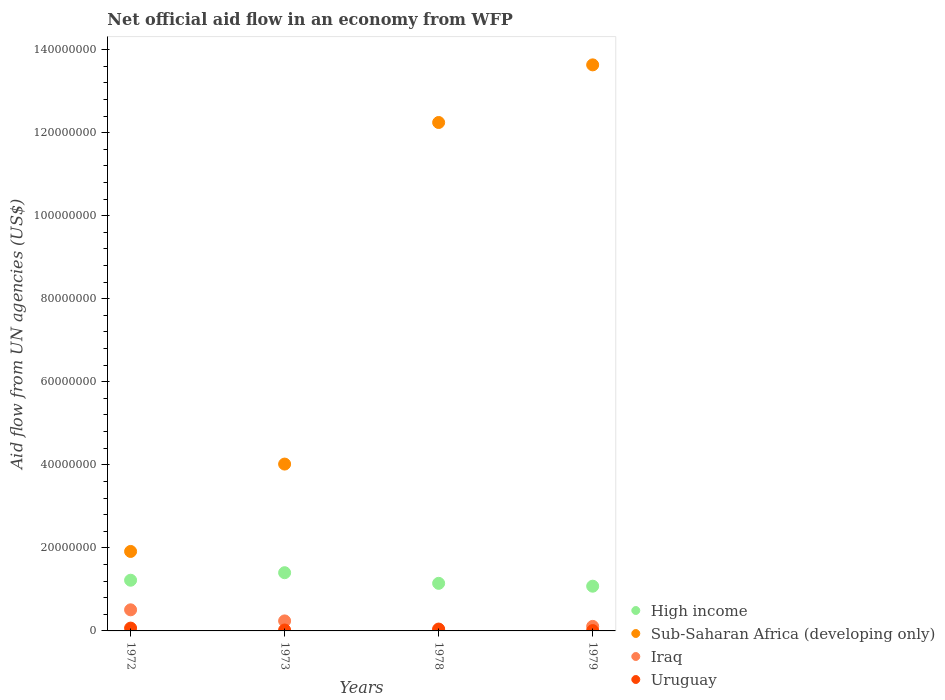Is the number of dotlines equal to the number of legend labels?
Provide a short and direct response. Yes. Across all years, what is the maximum net official aid flow in Sub-Saharan Africa (developing only)?
Make the answer very short. 1.36e+08. Across all years, what is the minimum net official aid flow in Uruguay?
Provide a short and direct response. 8.00e+04. In which year was the net official aid flow in Uruguay minimum?
Give a very brief answer. 1979. What is the total net official aid flow in High income in the graph?
Give a very brief answer. 4.85e+07. What is the difference between the net official aid flow in Sub-Saharan Africa (developing only) in 1973 and that in 1978?
Provide a succinct answer. -8.23e+07. What is the difference between the net official aid flow in High income in 1972 and the net official aid flow in Uruguay in 1978?
Provide a succinct answer. 1.18e+07. What is the average net official aid flow in High income per year?
Offer a terse response. 1.21e+07. In the year 1973, what is the difference between the net official aid flow in High income and net official aid flow in Iraq?
Your response must be concise. 1.16e+07. In how many years, is the net official aid flow in Uruguay greater than 60000000 US$?
Your answer should be very brief. 0. What is the ratio of the net official aid flow in Iraq in 1972 to that in 1978?
Ensure brevity in your answer.  22.09. What is the difference between the highest and the second highest net official aid flow in Iraq?
Offer a very short reply. 2.67e+06. Is the sum of the net official aid flow in Uruguay in 1972 and 1973 greater than the maximum net official aid flow in High income across all years?
Offer a very short reply. No. Is it the case that in every year, the sum of the net official aid flow in Iraq and net official aid flow in Uruguay  is greater than the sum of net official aid flow in Sub-Saharan Africa (developing only) and net official aid flow in High income?
Ensure brevity in your answer.  No. Is it the case that in every year, the sum of the net official aid flow in Sub-Saharan Africa (developing only) and net official aid flow in Iraq  is greater than the net official aid flow in Uruguay?
Offer a terse response. Yes. Does the net official aid flow in High income monotonically increase over the years?
Your answer should be compact. No. Is the net official aid flow in Uruguay strictly greater than the net official aid flow in High income over the years?
Your answer should be very brief. No. Does the graph contain any zero values?
Make the answer very short. No. Does the graph contain grids?
Make the answer very short. No. Where does the legend appear in the graph?
Your answer should be compact. Bottom right. How are the legend labels stacked?
Make the answer very short. Vertical. What is the title of the graph?
Keep it short and to the point. Net official aid flow in an economy from WFP. What is the label or title of the X-axis?
Give a very brief answer. Years. What is the label or title of the Y-axis?
Keep it short and to the point. Aid flow from UN agencies (US$). What is the Aid flow from UN agencies (US$) of High income in 1972?
Your response must be concise. 1.22e+07. What is the Aid flow from UN agencies (US$) in Sub-Saharan Africa (developing only) in 1972?
Offer a very short reply. 1.91e+07. What is the Aid flow from UN agencies (US$) of Iraq in 1972?
Make the answer very short. 5.08e+06. What is the Aid flow from UN agencies (US$) in Uruguay in 1972?
Make the answer very short. 6.80e+05. What is the Aid flow from UN agencies (US$) in High income in 1973?
Make the answer very short. 1.40e+07. What is the Aid flow from UN agencies (US$) of Sub-Saharan Africa (developing only) in 1973?
Your answer should be compact. 4.02e+07. What is the Aid flow from UN agencies (US$) of Iraq in 1973?
Provide a short and direct response. 2.41e+06. What is the Aid flow from UN agencies (US$) of Uruguay in 1973?
Your response must be concise. 2.20e+05. What is the Aid flow from UN agencies (US$) in High income in 1978?
Keep it short and to the point. 1.15e+07. What is the Aid flow from UN agencies (US$) of Sub-Saharan Africa (developing only) in 1978?
Ensure brevity in your answer.  1.22e+08. What is the Aid flow from UN agencies (US$) in High income in 1979?
Provide a short and direct response. 1.08e+07. What is the Aid flow from UN agencies (US$) of Sub-Saharan Africa (developing only) in 1979?
Offer a terse response. 1.36e+08. What is the Aid flow from UN agencies (US$) in Iraq in 1979?
Ensure brevity in your answer.  1.09e+06. Across all years, what is the maximum Aid flow from UN agencies (US$) of High income?
Keep it short and to the point. 1.40e+07. Across all years, what is the maximum Aid flow from UN agencies (US$) of Sub-Saharan Africa (developing only)?
Provide a succinct answer. 1.36e+08. Across all years, what is the maximum Aid flow from UN agencies (US$) of Iraq?
Your answer should be compact. 5.08e+06. Across all years, what is the maximum Aid flow from UN agencies (US$) in Uruguay?
Provide a short and direct response. 6.80e+05. Across all years, what is the minimum Aid flow from UN agencies (US$) in High income?
Keep it short and to the point. 1.08e+07. Across all years, what is the minimum Aid flow from UN agencies (US$) of Sub-Saharan Africa (developing only)?
Provide a succinct answer. 1.91e+07. Across all years, what is the minimum Aid flow from UN agencies (US$) in Uruguay?
Offer a terse response. 8.00e+04. What is the total Aid flow from UN agencies (US$) of High income in the graph?
Offer a terse response. 4.85e+07. What is the total Aid flow from UN agencies (US$) of Sub-Saharan Africa (developing only) in the graph?
Offer a very short reply. 3.18e+08. What is the total Aid flow from UN agencies (US$) of Iraq in the graph?
Your response must be concise. 8.81e+06. What is the total Aid flow from UN agencies (US$) of Uruguay in the graph?
Ensure brevity in your answer.  1.43e+06. What is the difference between the Aid flow from UN agencies (US$) of High income in 1972 and that in 1973?
Your answer should be compact. -1.81e+06. What is the difference between the Aid flow from UN agencies (US$) of Sub-Saharan Africa (developing only) in 1972 and that in 1973?
Your response must be concise. -2.10e+07. What is the difference between the Aid flow from UN agencies (US$) of Iraq in 1972 and that in 1973?
Your response must be concise. 2.67e+06. What is the difference between the Aid flow from UN agencies (US$) of Uruguay in 1972 and that in 1973?
Offer a very short reply. 4.60e+05. What is the difference between the Aid flow from UN agencies (US$) in High income in 1972 and that in 1978?
Give a very brief answer. 7.50e+05. What is the difference between the Aid flow from UN agencies (US$) of Sub-Saharan Africa (developing only) in 1972 and that in 1978?
Your answer should be very brief. -1.03e+08. What is the difference between the Aid flow from UN agencies (US$) in Iraq in 1972 and that in 1978?
Give a very brief answer. 4.85e+06. What is the difference between the Aid flow from UN agencies (US$) of High income in 1972 and that in 1979?
Keep it short and to the point. 1.44e+06. What is the difference between the Aid flow from UN agencies (US$) of Sub-Saharan Africa (developing only) in 1972 and that in 1979?
Your response must be concise. -1.17e+08. What is the difference between the Aid flow from UN agencies (US$) of Iraq in 1972 and that in 1979?
Give a very brief answer. 3.99e+06. What is the difference between the Aid flow from UN agencies (US$) in High income in 1973 and that in 1978?
Provide a short and direct response. 2.56e+06. What is the difference between the Aid flow from UN agencies (US$) of Sub-Saharan Africa (developing only) in 1973 and that in 1978?
Ensure brevity in your answer.  -8.23e+07. What is the difference between the Aid flow from UN agencies (US$) of Iraq in 1973 and that in 1978?
Keep it short and to the point. 2.18e+06. What is the difference between the Aid flow from UN agencies (US$) in Uruguay in 1973 and that in 1978?
Offer a terse response. -2.30e+05. What is the difference between the Aid flow from UN agencies (US$) of High income in 1973 and that in 1979?
Your response must be concise. 3.25e+06. What is the difference between the Aid flow from UN agencies (US$) of Sub-Saharan Africa (developing only) in 1973 and that in 1979?
Provide a short and direct response. -9.61e+07. What is the difference between the Aid flow from UN agencies (US$) in Iraq in 1973 and that in 1979?
Keep it short and to the point. 1.32e+06. What is the difference between the Aid flow from UN agencies (US$) in Uruguay in 1973 and that in 1979?
Offer a terse response. 1.40e+05. What is the difference between the Aid flow from UN agencies (US$) in High income in 1978 and that in 1979?
Give a very brief answer. 6.90e+05. What is the difference between the Aid flow from UN agencies (US$) of Sub-Saharan Africa (developing only) in 1978 and that in 1979?
Your response must be concise. -1.39e+07. What is the difference between the Aid flow from UN agencies (US$) in Iraq in 1978 and that in 1979?
Provide a short and direct response. -8.60e+05. What is the difference between the Aid flow from UN agencies (US$) of High income in 1972 and the Aid flow from UN agencies (US$) of Sub-Saharan Africa (developing only) in 1973?
Give a very brief answer. -2.80e+07. What is the difference between the Aid flow from UN agencies (US$) of High income in 1972 and the Aid flow from UN agencies (US$) of Iraq in 1973?
Your answer should be very brief. 9.80e+06. What is the difference between the Aid flow from UN agencies (US$) of High income in 1972 and the Aid flow from UN agencies (US$) of Uruguay in 1973?
Provide a succinct answer. 1.20e+07. What is the difference between the Aid flow from UN agencies (US$) in Sub-Saharan Africa (developing only) in 1972 and the Aid flow from UN agencies (US$) in Iraq in 1973?
Give a very brief answer. 1.67e+07. What is the difference between the Aid flow from UN agencies (US$) of Sub-Saharan Africa (developing only) in 1972 and the Aid flow from UN agencies (US$) of Uruguay in 1973?
Your answer should be very brief. 1.89e+07. What is the difference between the Aid flow from UN agencies (US$) of Iraq in 1972 and the Aid flow from UN agencies (US$) of Uruguay in 1973?
Ensure brevity in your answer.  4.86e+06. What is the difference between the Aid flow from UN agencies (US$) in High income in 1972 and the Aid flow from UN agencies (US$) in Sub-Saharan Africa (developing only) in 1978?
Your response must be concise. -1.10e+08. What is the difference between the Aid flow from UN agencies (US$) in High income in 1972 and the Aid flow from UN agencies (US$) in Iraq in 1978?
Ensure brevity in your answer.  1.20e+07. What is the difference between the Aid flow from UN agencies (US$) in High income in 1972 and the Aid flow from UN agencies (US$) in Uruguay in 1978?
Ensure brevity in your answer.  1.18e+07. What is the difference between the Aid flow from UN agencies (US$) of Sub-Saharan Africa (developing only) in 1972 and the Aid flow from UN agencies (US$) of Iraq in 1978?
Your response must be concise. 1.89e+07. What is the difference between the Aid flow from UN agencies (US$) in Sub-Saharan Africa (developing only) in 1972 and the Aid flow from UN agencies (US$) in Uruguay in 1978?
Give a very brief answer. 1.87e+07. What is the difference between the Aid flow from UN agencies (US$) in Iraq in 1972 and the Aid flow from UN agencies (US$) in Uruguay in 1978?
Offer a very short reply. 4.63e+06. What is the difference between the Aid flow from UN agencies (US$) in High income in 1972 and the Aid flow from UN agencies (US$) in Sub-Saharan Africa (developing only) in 1979?
Offer a very short reply. -1.24e+08. What is the difference between the Aid flow from UN agencies (US$) in High income in 1972 and the Aid flow from UN agencies (US$) in Iraq in 1979?
Provide a succinct answer. 1.11e+07. What is the difference between the Aid flow from UN agencies (US$) of High income in 1972 and the Aid flow from UN agencies (US$) of Uruguay in 1979?
Provide a succinct answer. 1.21e+07. What is the difference between the Aid flow from UN agencies (US$) of Sub-Saharan Africa (developing only) in 1972 and the Aid flow from UN agencies (US$) of Iraq in 1979?
Give a very brief answer. 1.80e+07. What is the difference between the Aid flow from UN agencies (US$) of Sub-Saharan Africa (developing only) in 1972 and the Aid flow from UN agencies (US$) of Uruguay in 1979?
Provide a short and direct response. 1.91e+07. What is the difference between the Aid flow from UN agencies (US$) of High income in 1973 and the Aid flow from UN agencies (US$) of Sub-Saharan Africa (developing only) in 1978?
Make the answer very short. -1.08e+08. What is the difference between the Aid flow from UN agencies (US$) of High income in 1973 and the Aid flow from UN agencies (US$) of Iraq in 1978?
Give a very brief answer. 1.38e+07. What is the difference between the Aid flow from UN agencies (US$) in High income in 1973 and the Aid flow from UN agencies (US$) in Uruguay in 1978?
Offer a very short reply. 1.36e+07. What is the difference between the Aid flow from UN agencies (US$) of Sub-Saharan Africa (developing only) in 1973 and the Aid flow from UN agencies (US$) of Iraq in 1978?
Your answer should be compact. 4.00e+07. What is the difference between the Aid flow from UN agencies (US$) of Sub-Saharan Africa (developing only) in 1973 and the Aid flow from UN agencies (US$) of Uruguay in 1978?
Offer a very short reply. 3.97e+07. What is the difference between the Aid flow from UN agencies (US$) in Iraq in 1973 and the Aid flow from UN agencies (US$) in Uruguay in 1978?
Offer a terse response. 1.96e+06. What is the difference between the Aid flow from UN agencies (US$) of High income in 1973 and the Aid flow from UN agencies (US$) of Sub-Saharan Africa (developing only) in 1979?
Provide a succinct answer. -1.22e+08. What is the difference between the Aid flow from UN agencies (US$) of High income in 1973 and the Aid flow from UN agencies (US$) of Iraq in 1979?
Your answer should be compact. 1.29e+07. What is the difference between the Aid flow from UN agencies (US$) in High income in 1973 and the Aid flow from UN agencies (US$) in Uruguay in 1979?
Offer a terse response. 1.39e+07. What is the difference between the Aid flow from UN agencies (US$) of Sub-Saharan Africa (developing only) in 1973 and the Aid flow from UN agencies (US$) of Iraq in 1979?
Offer a terse response. 3.91e+07. What is the difference between the Aid flow from UN agencies (US$) of Sub-Saharan Africa (developing only) in 1973 and the Aid flow from UN agencies (US$) of Uruguay in 1979?
Your answer should be very brief. 4.01e+07. What is the difference between the Aid flow from UN agencies (US$) in Iraq in 1973 and the Aid flow from UN agencies (US$) in Uruguay in 1979?
Provide a succinct answer. 2.33e+06. What is the difference between the Aid flow from UN agencies (US$) of High income in 1978 and the Aid flow from UN agencies (US$) of Sub-Saharan Africa (developing only) in 1979?
Your answer should be very brief. -1.25e+08. What is the difference between the Aid flow from UN agencies (US$) in High income in 1978 and the Aid flow from UN agencies (US$) in Iraq in 1979?
Provide a short and direct response. 1.04e+07. What is the difference between the Aid flow from UN agencies (US$) in High income in 1978 and the Aid flow from UN agencies (US$) in Uruguay in 1979?
Your answer should be compact. 1.14e+07. What is the difference between the Aid flow from UN agencies (US$) of Sub-Saharan Africa (developing only) in 1978 and the Aid flow from UN agencies (US$) of Iraq in 1979?
Ensure brevity in your answer.  1.21e+08. What is the difference between the Aid flow from UN agencies (US$) of Sub-Saharan Africa (developing only) in 1978 and the Aid flow from UN agencies (US$) of Uruguay in 1979?
Make the answer very short. 1.22e+08. What is the difference between the Aid flow from UN agencies (US$) in Iraq in 1978 and the Aid flow from UN agencies (US$) in Uruguay in 1979?
Provide a short and direct response. 1.50e+05. What is the average Aid flow from UN agencies (US$) of High income per year?
Offer a very short reply. 1.21e+07. What is the average Aid flow from UN agencies (US$) of Sub-Saharan Africa (developing only) per year?
Ensure brevity in your answer.  7.95e+07. What is the average Aid flow from UN agencies (US$) in Iraq per year?
Your answer should be very brief. 2.20e+06. What is the average Aid flow from UN agencies (US$) of Uruguay per year?
Give a very brief answer. 3.58e+05. In the year 1972, what is the difference between the Aid flow from UN agencies (US$) in High income and Aid flow from UN agencies (US$) in Sub-Saharan Africa (developing only)?
Your answer should be compact. -6.93e+06. In the year 1972, what is the difference between the Aid flow from UN agencies (US$) in High income and Aid flow from UN agencies (US$) in Iraq?
Ensure brevity in your answer.  7.13e+06. In the year 1972, what is the difference between the Aid flow from UN agencies (US$) in High income and Aid flow from UN agencies (US$) in Uruguay?
Give a very brief answer. 1.15e+07. In the year 1972, what is the difference between the Aid flow from UN agencies (US$) of Sub-Saharan Africa (developing only) and Aid flow from UN agencies (US$) of Iraq?
Provide a succinct answer. 1.41e+07. In the year 1972, what is the difference between the Aid flow from UN agencies (US$) in Sub-Saharan Africa (developing only) and Aid flow from UN agencies (US$) in Uruguay?
Give a very brief answer. 1.85e+07. In the year 1972, what is the difference between the Aid flow from UN agencies (US$) in Iraq and Aid flow from UN agencies (US$) in Uruguay?
Your answer should be very brief. 4.40e+06. In the year 1973, what is the difference between the Aid flow from UN agencies (US$) of High income and Aid flow from UN agencies (US$) of Sub-Saharan Africa (developing only)?
Give a very brief answer. -2.62e+07. In the year 1973, what is the difference between the Aid flow from UN agencies (US$) of High income and Aid flow from UN agencies (US$) of Iraq?
Ensure brevity in your answer.  1.16e+07. In the year 1973, what is the difference between the Aid flow from UN agencies (US$) in High income and Aid flow from UN agencies (US$) in Uruguay?
Give a very brief answer. 1.38e+07. In the year 1973, what is the difference between the Aid flow from UN agencies (US$) in Sub-Saharan Africa (developing only) and Aid flow from UN agencies (US$) in Iraq?
Provide a succinct answer. 3.78e+07. In the year 1973, what is the difference between the Aid flow from UN agencies (US$) in Sub-Saharan Africa (developing only) and Aid flow from UN agencies (US$) in Uruguay?
Offer a very short reply. 4.00e+07. In the year 1973, what is the difference between the Aid flow from UN agencies (US$) in Iraq and Aid flow from UN agencies (US$) in Uruguay?
Provide a succinct answer. 2.19e+06. In the year 1978, what is the difference between the Aid flow from UN agencies (US$) in High income and Aid flow from UN agencies (US$) in Sub-Saharan Africa (developing only)?
Your answer should be compact. -1.11e+08. In the year 1978, what is the difference between the Aid flow from UN agencies (US$) of High income and Aid flow from UN agencies (US$) of Iraq?
Offer a terse response. 1.12e+07. In the year 1978, what is the difference between the Aid flow from UN agencies (US$) of High income and Aid flow from UN agencies (US$) of Uruguay?
Your answer should be very brief. 1.10e+07. In the year 1978, what is the difference between the Aid flow from UN agencies (US$) in Sub-Saharan Africa (developing only) and Aid flow from UN agencies (US$) in Iraq?
Give a very brief answer. 1.22e+08. In the year 1978, what is the difference between the Aid flow from UN agencies (US$) in Sub-Saharan Africa (developing only) and Aid flow from UN agencies (US$) in Uruguay?
Keep it short and to the point. 1.22e+08. In the year 1979, what is the difference between the Aid flow from UN agencies (US$) in High income and Aid flow from UN agencies (US$) in Sub-Saharan Africa (developing only)?
Make the answer very short. -1.26e+08. In the year 1979, what is the difference between the Aid flow from UN agencies (US$) of High income and Aid flow from UN agencies (US$) of Iraq?
Ensure brevity in your answer.  9.68e+06. In the year 1979, what is the difference between the Aid flow from UN agencies (US$) of High income and Aid flow from UN agencies (US$) of Uruguay?
Keep it short and to the point. 1.07e+07. In the year 1979, what is the difference between the Aid flow from UN agencies (US$) in Sub-Saharan Africa (developing only) and Aid flow from UN agencies (US$) in Iraq?
Provide a succinct answer. 1.35e+08. In the year 1979, what is the difference between the Aid flow from UN agencies (US$) in Sub-Saharan Africa (developing only) and Aid flow from UN agencies (US$) in Uruguay?
Your answer should be compact. 1.36e+08. In the year 1979, what is the difference between the Aid flow from UN agencies (US$) in Iraq and Aid flow from UN agencies (US$) in Uruguay?
Provide a short and direct response. 1.01e+06. What is the ratio of the Aid flow from UN agencies (US$) in High income in 1972 to that in 1973?
Your answer should be very brief. 0.87. What is the ratio of the Aid flow from UN agencies (US$) in Sub-Saharan Africa (developing only) in 1972 to that in 1973?
Offer a terse response. 0.48. What is the ratio of the Aid flow from UN agencies (US$) in Iraq in 1972 to that in 1973?
Offer a very short reply. 2.11. What is the ratio of the Aid flow from UN agencies (US$) of Uruguay in 1972 to that in 1973?
Make the answer very short. 3.09. What is the ratio of the Aid flow from UN agencies (US$) of High income in 1972 to that in 1978?
Make the answer very short. 1.07. What is the ratio of the Aid flow from UN agencies (US$) of Sub-Saharan Africa (developing only) in 1972 to that in 1978?
Offer a very short reply. 0.16. What is the ratio of the Aid flow from UN agencies (US$) in Iraq in 1972 to that in 1978?
Your answer should be compact. 22.09. What is the ratio of the Aid flow from UN agencies (US$) of Uruguay in 1972 to that in 1978?
Give a very brief answer. 1.51. What is the ratio of the Aid flow from UN agencies (US$) in High income in 1972 to that in 1979?
Ensure brevity in your answer.  1.13. What is the ratio of the Aid flow from UN agencies (US$) of Sub-Saharan Africa (developing only) in 1972 to that in 1979?
Ensure brevity in your answer.  0.14. What is the ratio of the Aid flow from UN agencies (US$) of Iraq in 1972 to that in 1979?
Give a very brief answer. 4.66. What is the ratio of the Aid flow from UN agencies (US$) in Uruguay in 1972 to that in 1979?
Ensure brevity in your answer.  8.5. What is the ratio of the Aid flow from UN agencies (US$) of High income in 1973 to that in 1978?
Your answer should be compact. 1.22. What is the ratio of the Aid flow from UN agencies (US$) in Sub-Saharan Africa (developing only) in 1973 to that in 1978?
Give a very brief answer. 0.33. What is the ratio of the Aid flow from UN agencies (US$) in Iraq in 1973 to that in 1978?
Provide a short and direct response. 10.48. What is the ratio of the Aid flow from UN agencies (US$) of Uruguay in 1973 to that in 1978?
Your answer should be very brief. 0.49. What is the ratio of the Aid flow from UN agencies (US$) of High income in 1973 to that in 1979?
Offer a very short reply. 1.3. What is the ratio of the Aid flow from UN agencies (US$) of Sub-Saharan Africa (developing only) in 1973 to that in 1979?
Offer a very short reply. 0.29. What is the ratio of the Aid flow from UN agencies (US$) of Iraq in 1973 to that in 1979?
Make the answer very short. 2.21. What is the ratio of the Aid flow from UN agencies (US$) in Uruguay in 1973 to that in 1979?
Give a very brief answer. 2.75. What is the ratio of the Aid flow from UN agencies (US$) of High income in 1978 to that in 1979?
Your answer should be very brief. 1.06. What is the ratio of the Aid flow from UN agencies (US$) of Sub-Saharan Africa (developing only) in 1978 to that in 1979?
Ensure brevity in your answer.  0.9. What is the ratio of the Aid flow from UN agencies (US$) in Iraq in 1978 to that in 1979?
Your answer should be very brief. 0.21. What is the ratio of the Aid flow from UN agencies (US$) of Uruguay in 1978 to that in 1979?
Provide a succinct answer. 5.62. What is the difference between the highest and the second highest Aid flow from UN agencies (US$) in High income?
Your answer should be compact. 1.81e+06. What is the difference between the highest and the second highest Aid flow from UN agencies (US$) in Sub-Saharan Africa (developing only)?
Offer a very short reply. 1.39e+07. What is the difference between the highest and the second highest Aid flow from UN agencies (US$) in Iraq?
Your answer should be very brief. 2.67e+06. What is the difference between the highest and the second highest Aid flow from UN agencies (US$) of Uruguay?
Give a very brief answer. 2.30e+05. What is the difference between the highest and the lowest Aid flow from UN agencies (US$) of High income?
Ensure brevity in your answer.  3.25e+06. What is the difference between the highest and the lowest Aid flow from UN agencies (US$) of Sub-Saharan Africa (developing only)?
Your answer should be compact. 1.17e+08. What is the difference between the highest and the lowest Aid flow from UN agencies (US$) of Iraq?
Your answer should be very brief. 4.85e+06. 